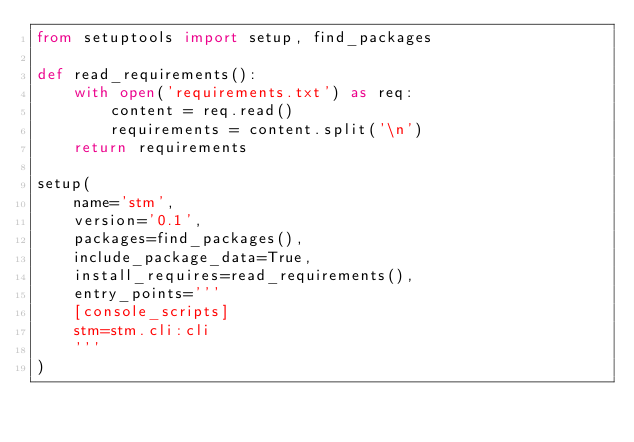Convert code to text. <code><loc_0><loc_0><loc_500><loc_500><_Python_>from setuptools import setup, find_packages

def read_requirements():
    with open('requirements.txt') as req:
        content = req.read()
        requirements = content.split('\n')
    return requirements

setup(
    name='stm',
    version='0.1',
    packages=find_packages(),
    include_package_data=True,
    install_requires=read_requirements(),
    entry_points='''
    [console_scripts]
    stm=stm.cli:cli
    '''
)</code> 